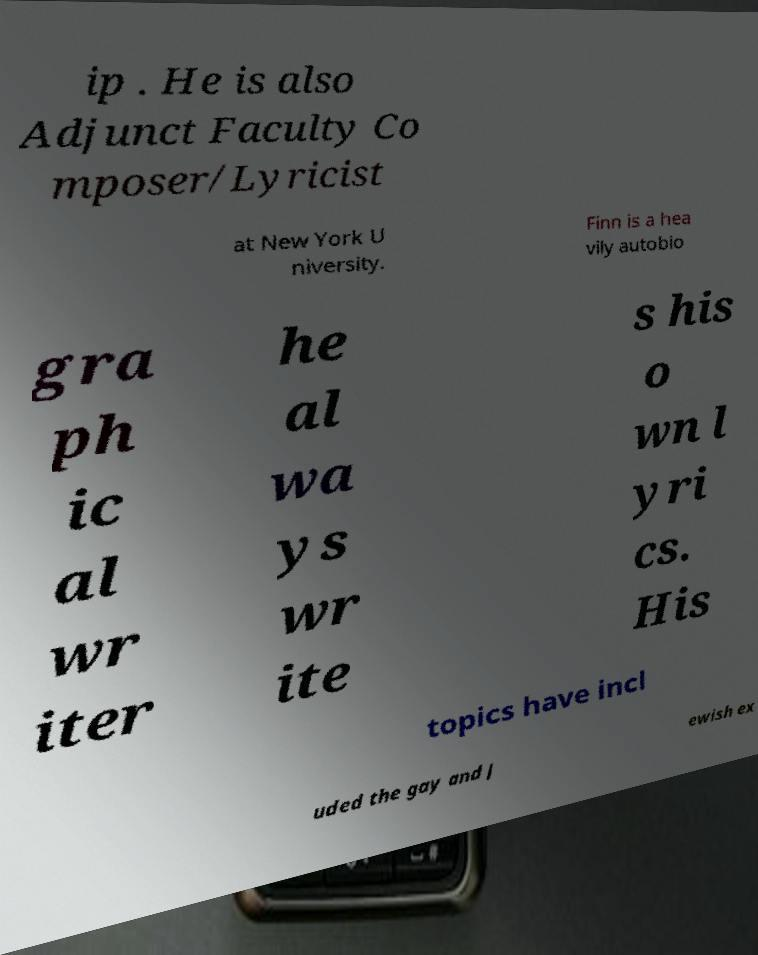Could you assist in decoding the text presented in this image and type it out clearly? ip . He is also Adjunct Faculty Co mposer/Lyricist at New York U niversity. Finn is a hea vily autobio gra ph ic al wr iter he al wa ys wr ite s his o wn l yri cs. His topics have incl uded the gay and J ewish ex 